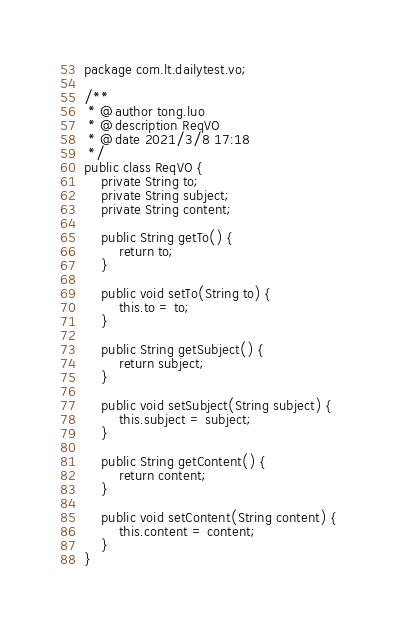Convert code to text. <code><loc_0><loc_0><loc_500><loc_500><_Java_>package com.lt.dailytest.vo;

/**
 * @author tong.luo
 * @description ReqVO
 * @date 2021/3/8 17:18
 */
public class ReqVO {
    private String to;
    private String subject;
    private String content;

    public String getTo() {
        return to;
    }

    public void setTo(String to) {
        this.to = to;
    }

    public String getSubject() {
        return subject;
    }

    public void setSubject(String subject) {
        this.subject = subject;
    }

    public String getContent() {
        return content;
    }

    public void setContent(String content) {
        this.content = content;
    }
}
</code> 